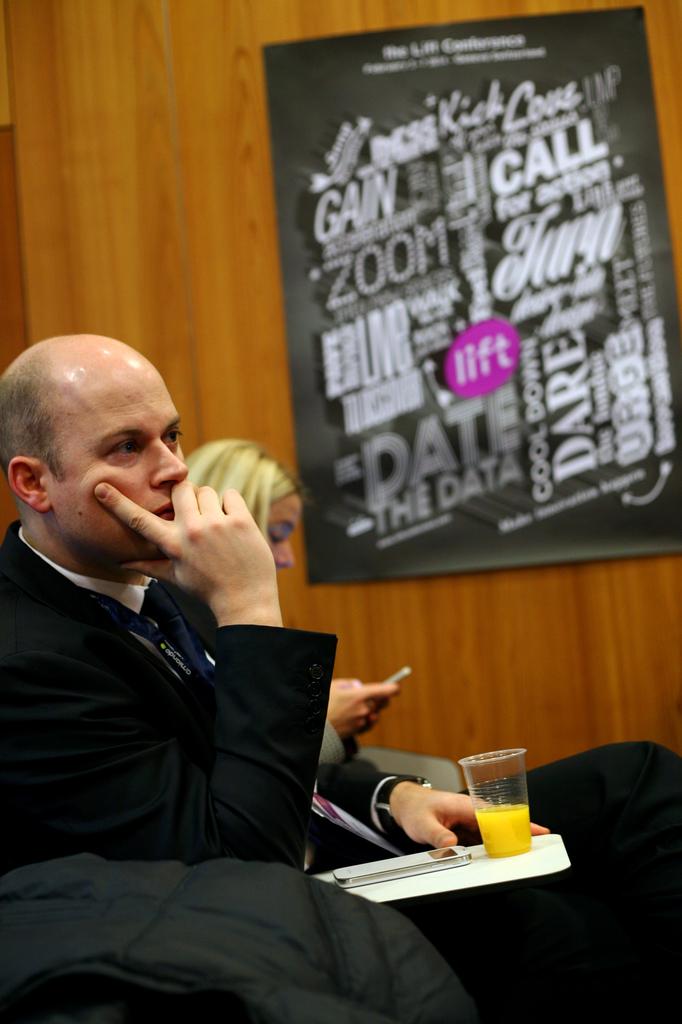What is on the poster?
Offer a terse response. Lift. What word means fast on the poster?
Your answer should be very brief. Zoom. 